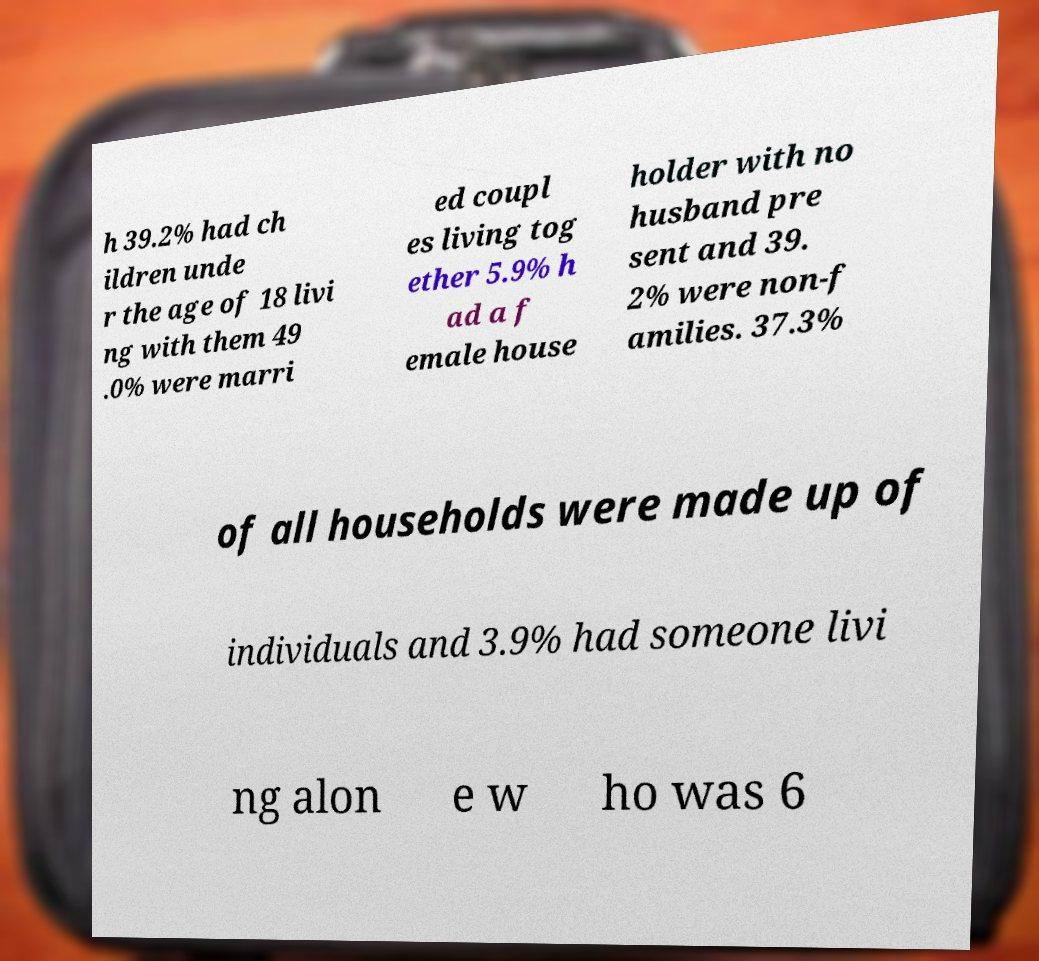Please read and relay the text visible in this image. What does it say? h 39.2% had ch ildren unde r the age of 18 livi ng with them 49 .0% were marri ed coupl es living tog ether 5.9% h ad a f emale house holder with no husband pre sent and 39. 2% were non-f amilies. 37.3% of all households were made up of individuals and 3.9% had someone livi ng alon e w ho was 6 